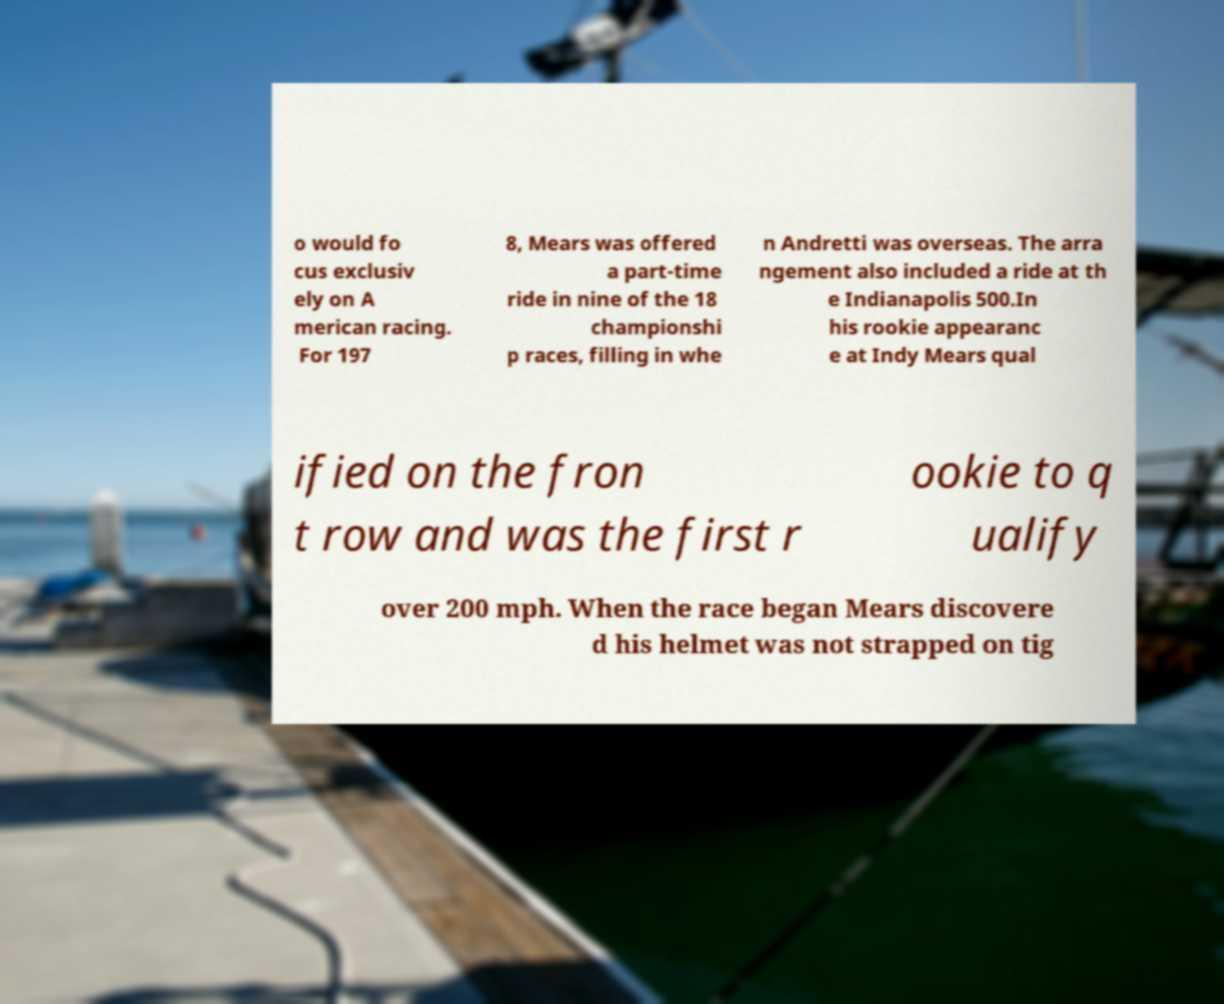Please read and relay the text visible in this image. What does it say? o would fo cus exclusiv ely on A merican racing. For 197 8, Mears was offered a part-time ride in nine of the 18 championshi p races, filling in whe n Andretti was overseas. The arra ngement also included a ride at th e Indianapolis 500.In his rookie appearanc e at Indy Mears qual ified on the fron t row and was the first r ookie to q ualify over 200 mph. When the race began Mears discovere d his helmet was not strapped on tig 